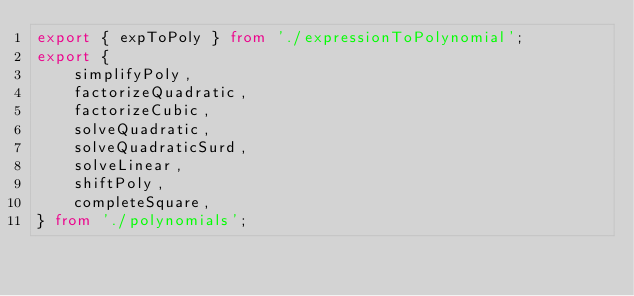<code> <loc_0><loc_0><loc_500><loc_500><_TypeScript_>export { expToPoly } from './expressionToPolynomial';
export {
	simplifyPoly,
	factorizeQuadratic,
	factorizeCubic,
	solveQuadratic,
	solveQuadraticSurd,
	solveLinear,
	shiftPoly,
	completeSquare,
} from './polynomials';
</code> 